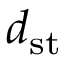<formula> <loc_0><loc_0><loc_500><loc_500>d _ { s t }</formula> 